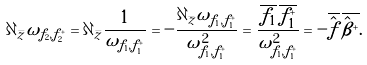Convert formula to latex. <formula><loc_0><loc_0><loc_500><loc_500>\partial _ { \bar { z } } \omega _ { \tilde { f } _ { 2 } , \tilde { f } _ { 2 } ^ { + } } = \partial _ { \bar { z } } \frac { 1 } { \omega _ { f _ { 1 } , f _ { 1 } ^ { + } } } = - \frac { \partial _ { \bar { z } } \omega _ { f _ { 1 } , f _ { 1 } ^ { + } } } { \omega ^ { 2 } _ { f _ { 1 } , f _ { 1 } ^ { + } } } = \frac { \overline { f _ { 1 } } \, \overline { f _ { 1 } ^ { + } } } { \omega ^ { 2 } _ { f _ { 1 } , f _ { 1 } ^ { + } } } = - \overline { \hat { f } } \, \overline { \hat { \beta } ^ { + } } .</formula> 